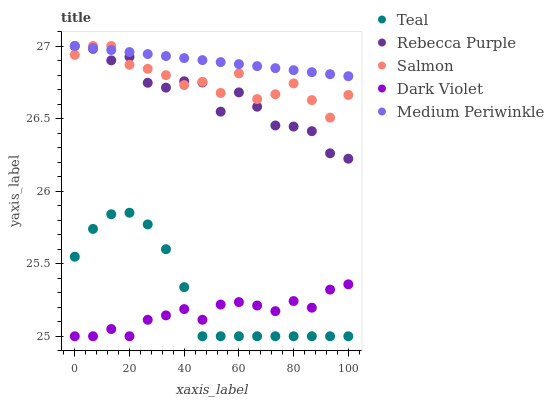Does Dark Violet have the minimum area under the curve?
Answer yes or no. Yes. Does Medium Periwinkle have the maximum area under the curve?
Answer yes or no. Yes. Does Salmon have the minimum area under the curve?
Answer yes or no. No. Does Salmon have the maximum area under the curve?
Answer yes or no. No. Is Medium Periwinkle the smoothest?
Answer yes or no. Yes. Is Rebecca Purple the roughest?
Answer yes or no. Yes. Is Dark Violet the smoothest?
Answer yes or no. No. Is Dark Violet the roughest?
Answer yes or no. No. Does Dark Violet have the lowest value?
Answer yes or no. Yes. Does Salmon have the lowest value?
Answer yes or no. No. Does Rebecca Purple have the highest value?
Answer yes or no. Yes. Does Dark Violet have the highest value?
Answer yes or no. No. Is Dark Violet less than Medium Periwinkle?
Answer yes or no. Yes. Is Medium Periwinkle greater than Dark Violet?
Answer yes or no. Yes. Does Medium Periwinkle intersect Salmon?
Answer yes or no. Yes. Is Medium Periwinkle less than Salmon?
Answer yes or no. No. Is Medium Periwinkle greater than Salmon?
Answer yes or no. No. Does Dark Violet intersect Medium Periwinkle?
Answer yes or no. No. 